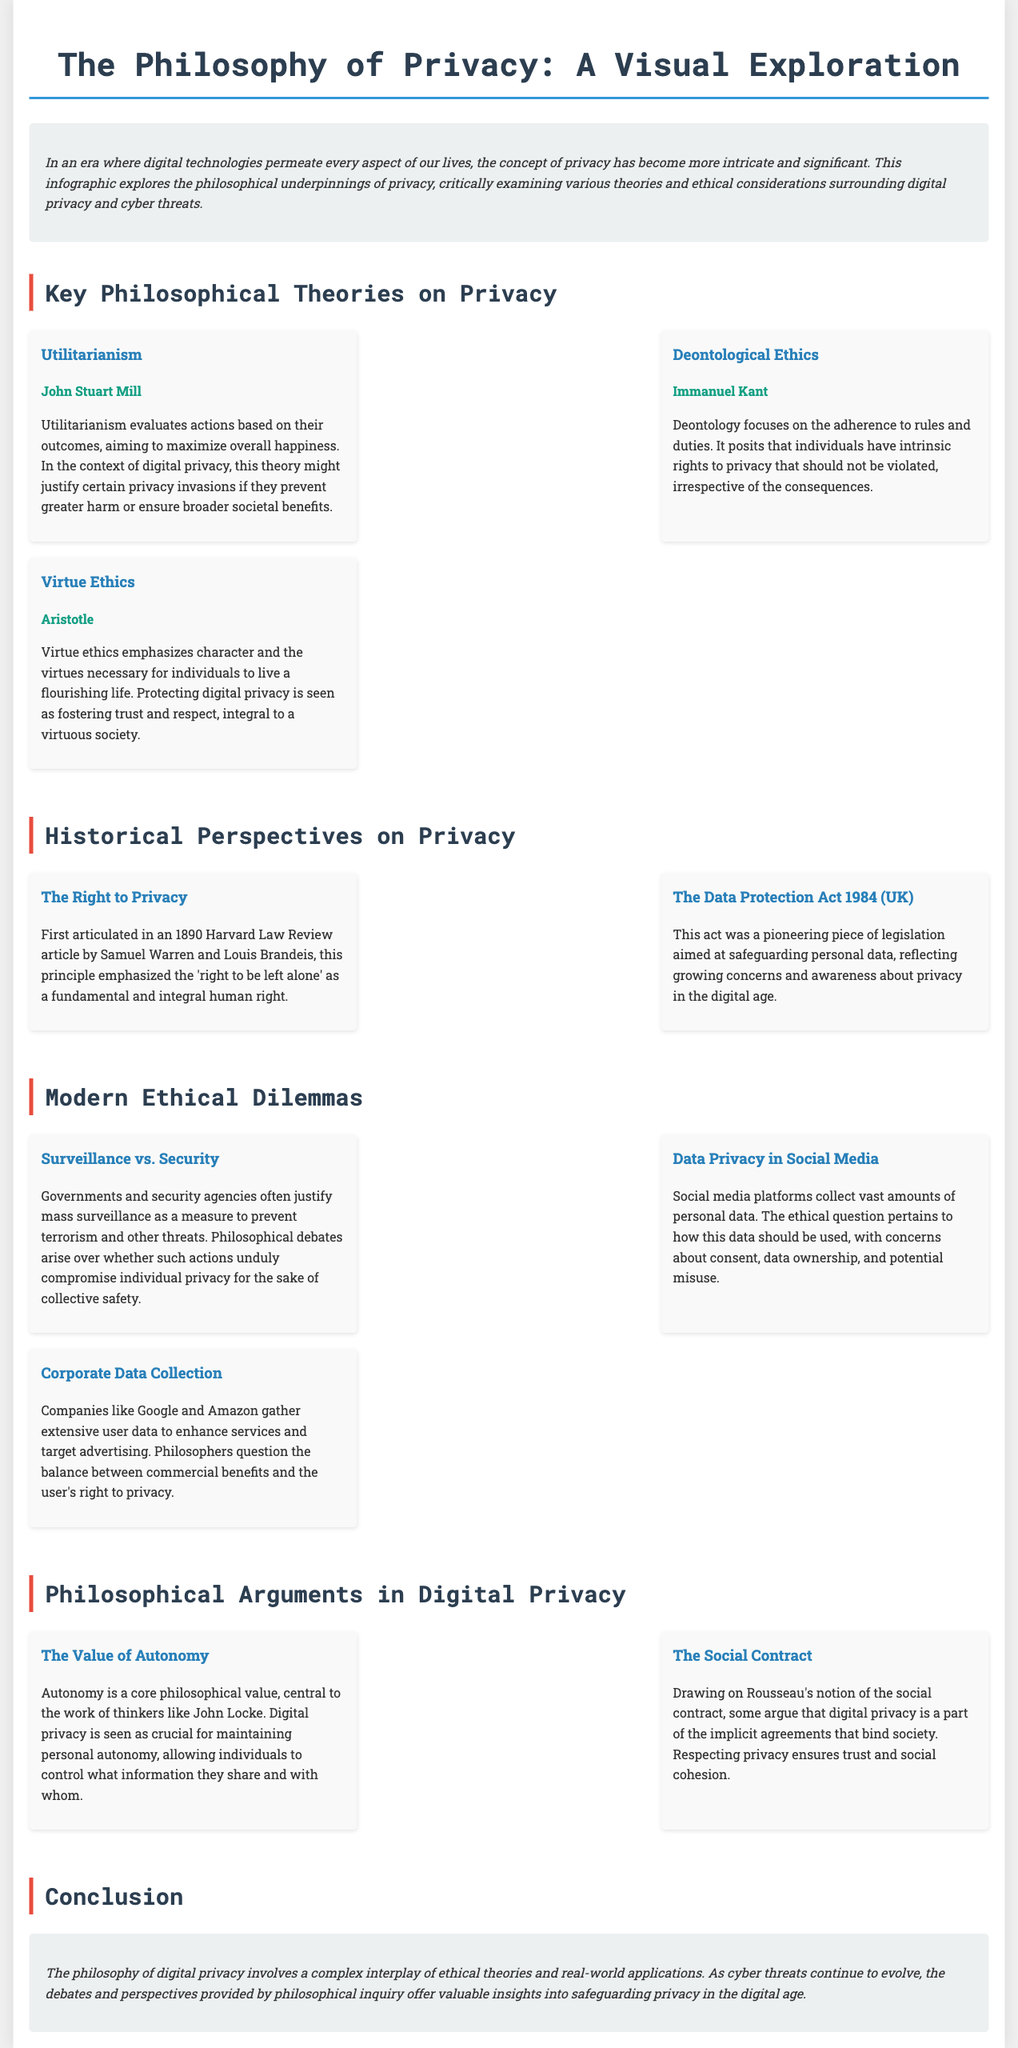what is the title of the infographic? The title is presented at the top of the document, summarizing the main topic.
Answer: The Philosophy of Privacy: A Visual Exploration who wrote about Utilitarianism in the context of privacy? The infographic attributes Utilitarianism to a specific philosopher, indicating who developed the theory.
Answer: John Stuart Mill when was the concept of 'the right to privacy' first articulated? The infographic includes a historical reference to when this principle was introduced, specifically identifying the year.
Answer: 1890 what is one ethical dilemma mentioned regarding corporate data collection? The infographic summarizes ethical questions specifically related to the data practices of companies, referencing their impact on privacy.
Answer: balance between commercial benefits and the user's right to privacy which philosophical value is emphasized as crucial for maintaining personal autonomy? The document states the importance of a specific value in relation to privacy, highlighting its role in autonomy.
Answer: Autonomy how is Virtue Ethics related to digital privacy? The infographic suggests a connection between Virtue Ethics and digital privacy, emphasizing the broader societal implications.
Answer: fostering trust and respect what act was a pioneering piece of legislation aimed at safeguarding personal data in the UK? The document explicitly mentions a specific law that reflects early efforts toward data protection in digital contexts.
Answer: The Data Protection Act 1984 what philosophical debate arises from mass surveillance? The infographic provides a specific dilemma that provokes philosophical discussions about the implications of surveillance.
Answer: whether such actions unduly compromise individual privacy for the sake of collective safety 